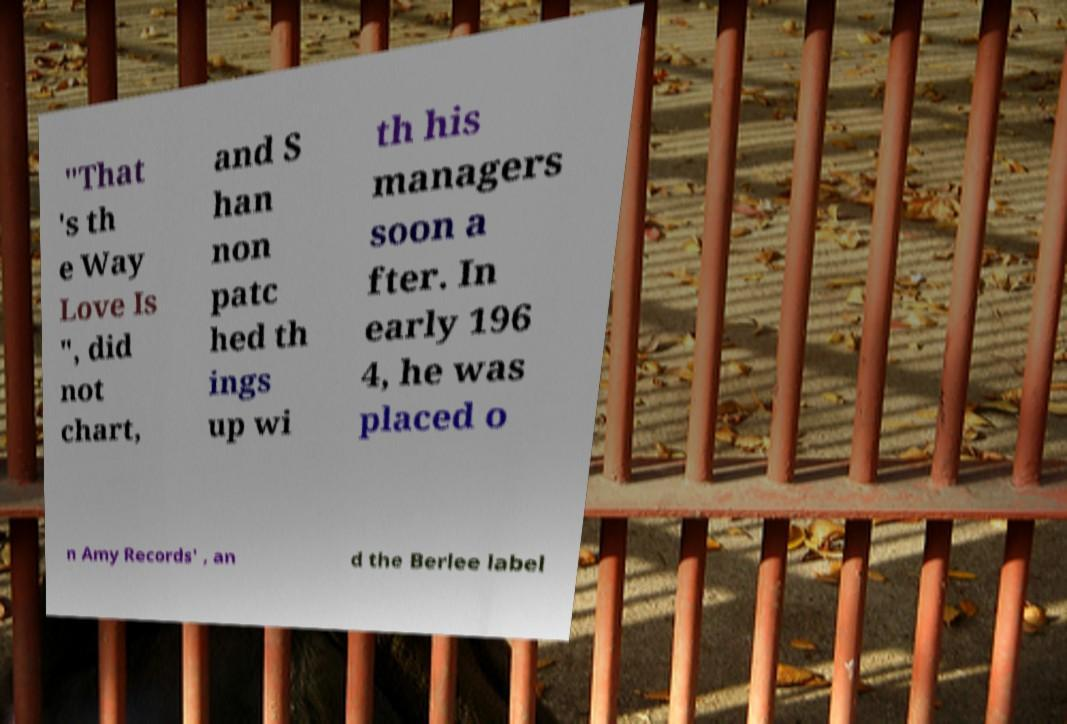Please identify and transcribe the text found in this image. "That 's th e Way Love Is ", did not chart, and S han non patc hed th ings up wi th his managers soon a fter. In early 196 4, he was placed o n Amy Records' , an d the Berlee label 